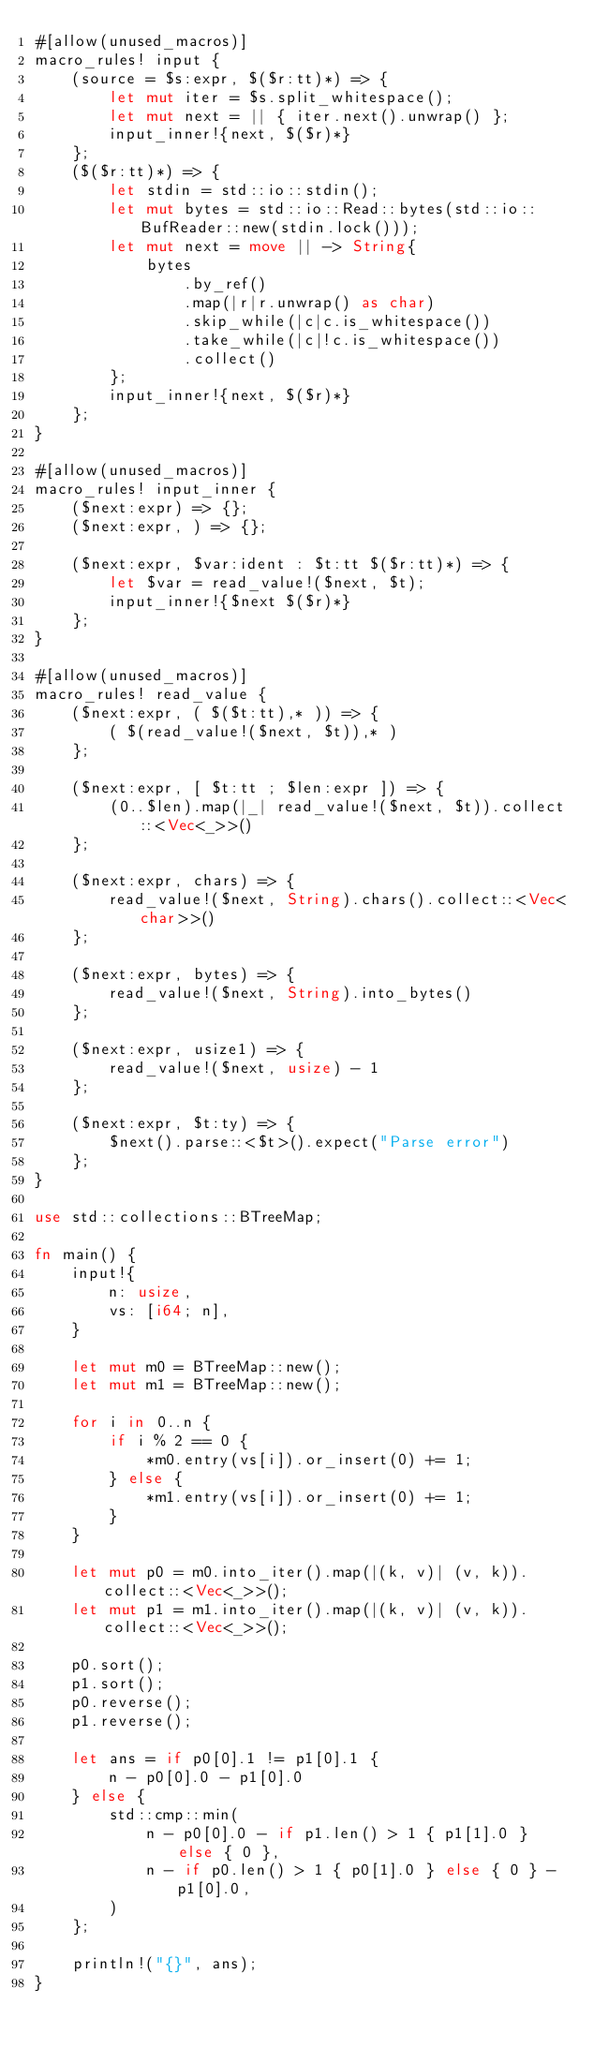<code> <loc_0><loc_0><loc_500><loc_500><_Rust_>#[allow(unused_macros)]
macro_rules! input {
    (source = $s:expr, $($r:tt)*) => {
        let mut iter = $s.split_whitespace();
        let mut next = || { iter.next().unwrap() };
        input_inner!{next, $($r)*}
    };
    ($($r:tt)*) => {
        let stdin = std::io::stdin();
        let mut bytes = std::io::Read::bytes(std::io::BufReader::new(stdin.lock()));
        let mut next = move || -> String{
            bytes
                .by_ref()
                .map(|r|r.unwrap() as char)
                .skip_while(|c|c.is_whitespace())
                .take_while(|c|!c.is_whitespace())
                .collect()
        };
        input_inner!{next, $($r)*}
    };
}

#[allow(unused_macros)]
macro_rules! input_inner {
    ($next:expr) => {};
    ($next:expr, ) => {};

    ($next:expr, $var:ident : $t:tt $($r:tt)*) => {
        let $var = read_value!($next, $t);
        input_inner!{$next $($r)*}
    };
}

#[allow(unused_macros)]
macro_rules! read_value {
    ($next:expr, ( $($t:tt),* )) => {
        ( $(read_value!($next, $t)),* )
    };

    ($next:expr, [ $t:tt ; $len:expr ]) => {
        (0..$len).map(|_| read_value!($next, $t)).collect::<Vec<_>>()
    };

    ($next:expr, chars) => {
        read_value!($next, String).chars().collect::<Vec<char>>()
    };

    ($next:expr, bytes) => {
        read_value!($next, String).into_bytes()
    };

    ($next:expr, usize1) => {
        read_value!($next, usize) - 1
    };

    ($next:expr, $t:ty) => {
        $next().parse::<$t>().expect("Parse error")
    };
}

use std::collections::BTreeMap;

fn main() {
    input!{
        n: usize,
        vs: [i64; n],
    }

    let mut m0 = BTreeMap::new();
    let mut m1 = BTreeMap::new();

    for i in 0..n {
        if i % 2 == 0 {
            *m0.entry(vs[i]).or_insert(0) += 1;
        } else {
            *m1.entry(vs[i]).or_insert(0) += 1;
        }
    }

    let mut p0 = m0.into_iter().map(|(k, v)| (v, k)).collect::<Vec<_>>();
    let mut p1 = m1.into_iter().map(|(k, v)| (v, k)).collect::<Vec<_>>();

    p0.sort();
    p1.sort();
    p0.reverse();
    p1.reverse();

    let ans = if p0[0].1 != p1[0].1 {
        n - p0[0].0 - p1[0].0
    } else {
        std::cmp::min(
            n - p0[0].0 - if p1.len() > 1 { p1[1].0 } else { 0 },
            n - if p0.len() > 1 { p0[1].0 } else { 0 } - p1[0].0,
        )
    };

    println!("{}", ans);
}
</code> 